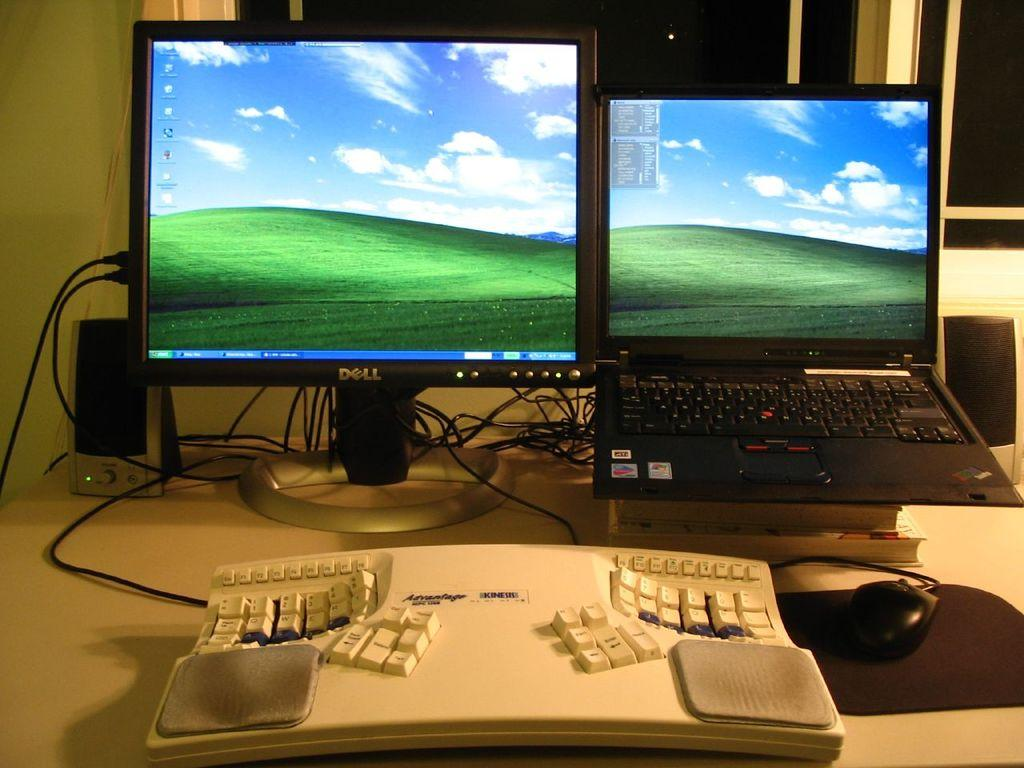<image>
Describe the image concisely. A dell computer computer is showing a plain desktop. 